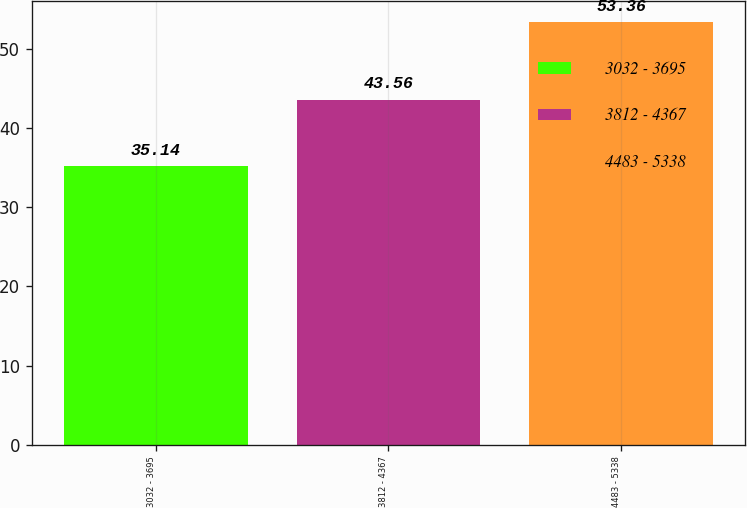<chart> <loc_0><loc_0><loc_500><loc_500><bar_chart><fcel>3032 - 3695<fcel>3812 - 4367<fcel>4483 - 5338<nl><fcel>35.14<fcel>43.56<fcel>53.36<nl></chart> 